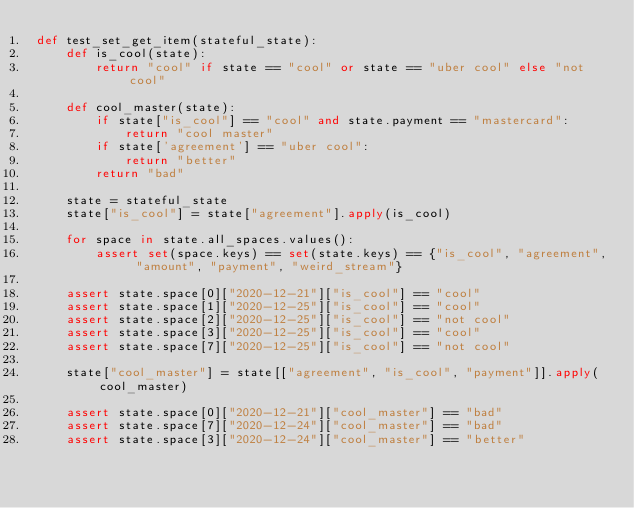<code> <loc_0><loc_0><loc_500><loc_500><_Python_>def test_set_get_item(stateful_state):
    def is_cool(state):
        return "cool" if state == "cool" or state == "uber cool" else "not cool"

    def cool_master(state):
        if state["is_cool"] == "cool" and state.payment == "mastercard":
            return "cool master"
        if state['agreement'] == "uber cool":
            return "better"
        return "bad"

    state = stateful_state
    state["is_cool"] = state["agreement"].apply(is_cool)

    for space in state.all_spaces.values():
        assert set(space.keys) == set(state.keys) == {"is_cool", "agreement", "amount", "payment", "weird_stream"}

    assert state.space[0]["2020-12-21"]["is_cool"] == "cool"
    assert state.space[1]["2020-12-25"]["is_cool"] == "cool"
    assert state.space[2]["2020-12-25"]["is_cool"] == "not cool"
    assert state.space[3]["2020-12-25"]["is_cool"] == "cool"
    assert state.space[7]["2020-12-25"]["is_cool"] == "not cool"

    state["cool_master"] = state[["agreement", "is_cool", "payment"]].apply(cool_master)

    assert state.space[0]["2020-12-21"]["cool_master"] == "bad"
    assert state.space[7]["2020-12-24"]["cool_master"] == "bad"
    assert state.space[3]["2020-12-24"]["cool_master"] == "better"
</code> 